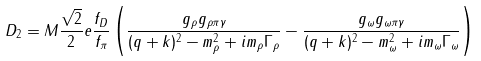<formula> <loc_0><loc_0><loc_500><loc_500>D _ { 2 } = M \frac { \sqrt { 2 } } { 2 } e \frac { f _ { D } } { f _ { \pi } } \left ( \frac { g _ { \rho } g _ { \rho \pi \gamma } } { ( q + k ) ^ { 2 } - m _ { \rho } ^ { 2 } + i m _ { \rho } \Gamma _ { \rho } } - \frac { g _ { \omega } g _ { \omega \pi \gamma } } { ( q + k ) ^ { 2 } - m _ { \omega } ^ { 2 } + i m _ { \omega } \Gamma _ { \omega } } \right )</formula> 